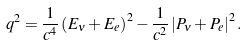Convert formula to latex. <formula><loc_0><loc_0><loc_500><loc_500>q ^ { 2 } = \frac { 1 } { c ^ { 4 } } \left ( E _ { \nu } + E _ { e } \right ) ^ { 2 } - \frac { 1 } { c ^ { 2 } } \left | { P } _ { \nu } + { P } _ { e } \right | ^ { 2 } .</formula> 